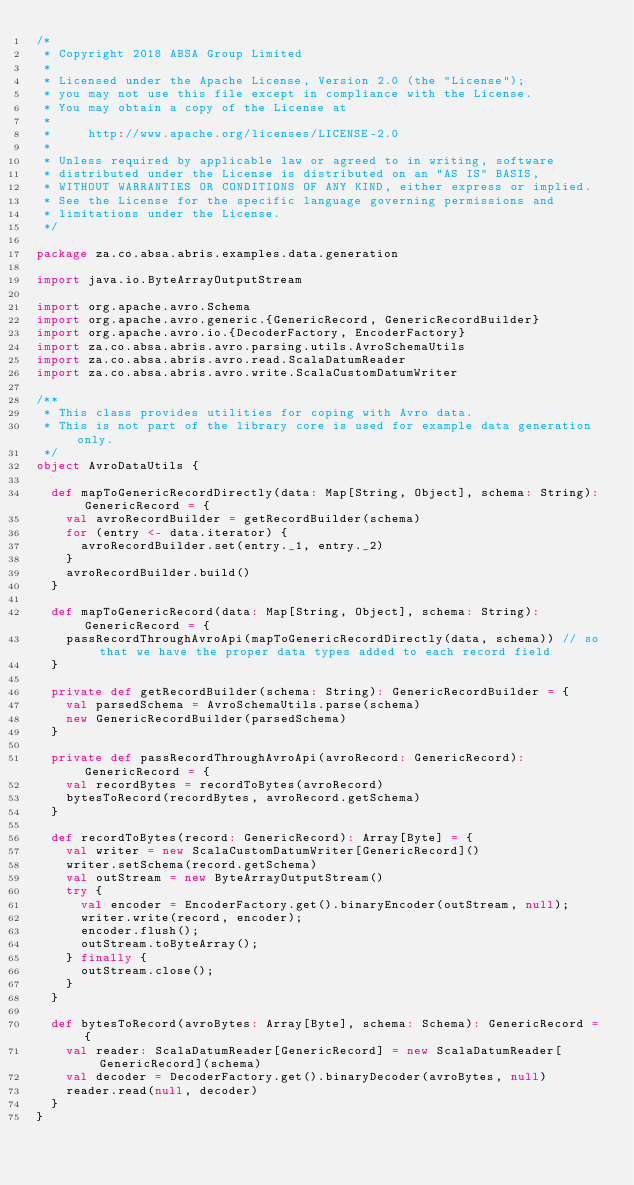Convert code to text. <code><loc_0><loc_0><loc_500><loc_500><_Scala_>/*
 * Copyright 2018 ABSA Group Limited
 *
 * Licensed under the Apache License, Version 2.0 (the "License");
 * you may not use this file except in compliance with the License.
 * You may obtain a copy of the License at
 *
 *     http://www.apache.org/licenses/LICENSE-2.0
 *
 * Unless required by applicable law or agreed to in writing, software
 * distributed under the License is distributed on an "AS IS" BASIS,
 * WITHOUT WARRANTIES OR CONDITIONS OF ANY KIND, either express or implied.
 * See the License for the specific language governing permissions and
 * limitations under the License.
 */

package za.co.absa.abris.examples.data.generation

import java.io.ByteArrayOutputStream

import org.apache.avro.Schema
import org.apache.avro.generic.{GenericRecord, GenericRecordBuilder}
import org.apache.avro.io.{DecoderFactory, EncoderFactory}
import za.co.absa.abris.avro.parsing.utils.AvroSchemaUtils
import za.co.absa.abris.avro.read.ScalaDatumReader
import za.co.absa.abris.avro.write.ScalaCustomDatumWriter

/**
 * This class provides utilities for coping with Avro data.
 * This is not part of the library core is used for example data generation only. 
 */
object AvroDataUtils {

  def mapToGenericRecordDirectly(data: Map[String, Object], schema: String): GenericRecord = {
    val avroRecordBuilder = getRecordBuilder(schema)
    for (entry <- data.iterator) {     
      avroRecordBuilder.set(entry._1, entry._2)
    }
    avroRecordBuilder.build()    
  }  
    
  def mapToGenericRecord(data: Map[String, Object], schema: String): GenericRecord = {
    passRecordThroughAvroApi(mapToGenericRecordDirectly(data, schema)) // so that we have the proper data types added to each record field
  }
  
  private def getRecordBuilder(schema: String): GenericRecordBuilder = {
    val parsedSchema = AvroSchemaUtils.parse(schema)
    new GenericRecordBuilder(parsedSchema)
  }
  
  private def passRecordThroughAvroApi(avroRecord: GenericRecord): GenericRecord = {
    val recordBytes = recordToBytes(avroRecord)
    bytesToRecord(recordBytes, avroRecord.getSchema)
  }

  def recordToBytes(record: GenericRecord): Array[Byte] = {
    val writer = new ScalaCustomDatumWriter[GenericRecord]()
    writer.setSchema(record.getSchema)
    val outStream = new ByteArrayOutputStream()
    try {
      val encoder = EncoderFactory.get().binaryEncoder(outStream, null);
      writer.write(record, encoder);
      encoder.flush();
      outStream.toByteArray();
    } finally {
      outStream.close();
    }
  }

  def bytesToRecord(avroBytes: Array[Byte], schema: Schema): GenericRecord = {
    val reader: ScalaDatumReader[GenericRecord] = new ScalaDatumReader[GenericRecord](schema)
    val decoder = DecoderFactory.get().binaryDecoder(avroBytes, null)
    reader.read(null, decoder)
  }
}</code> 